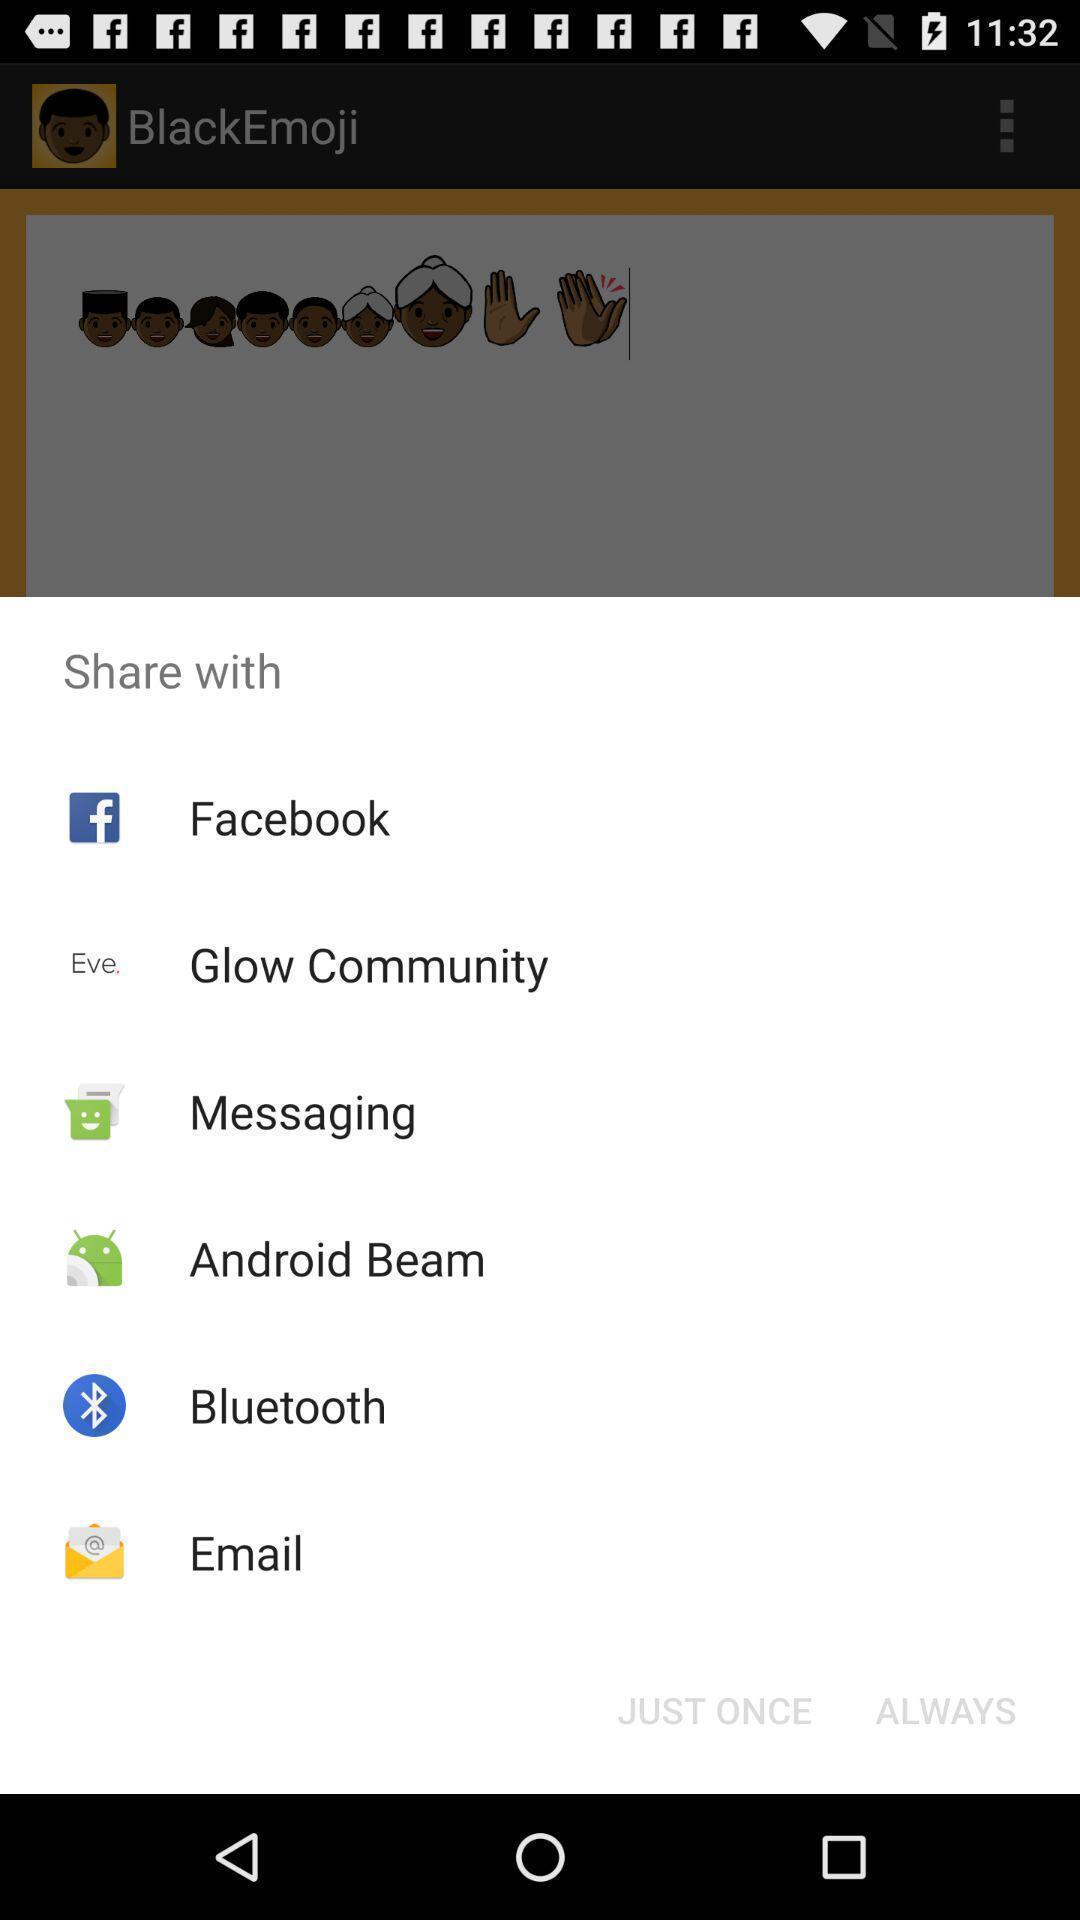Tell me what you see in this picture. Push up displaying multiple apps to share. 